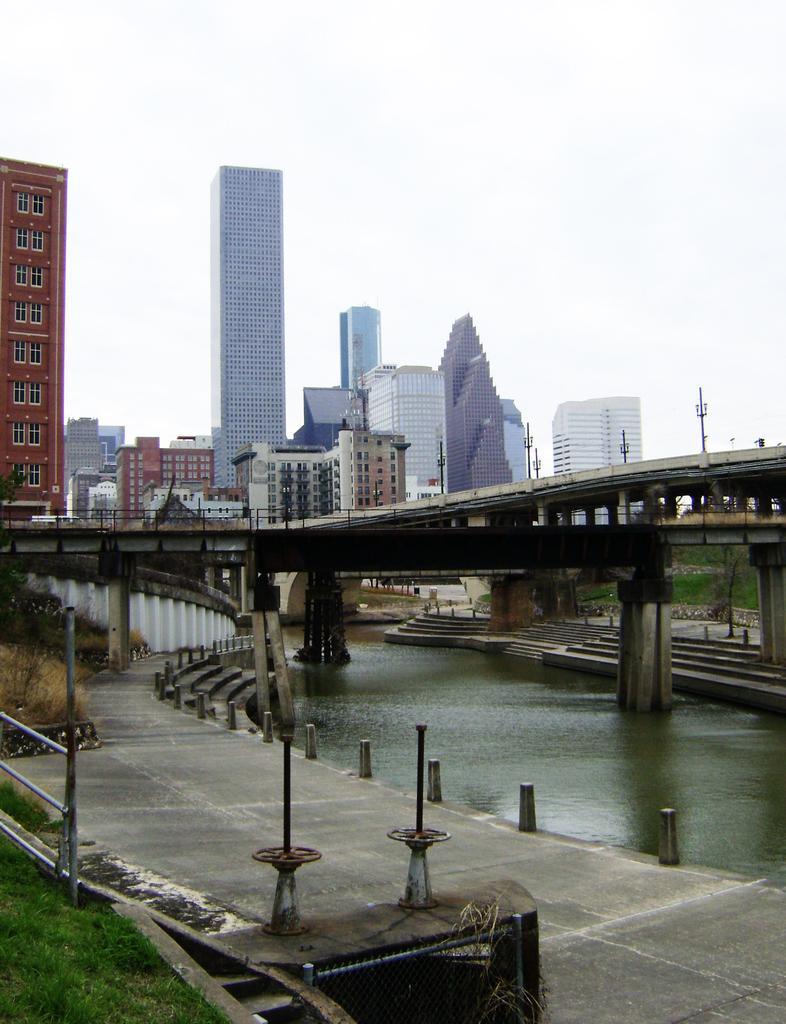Describe this image in one or two sentences. In this image we can see few bridges. We can see the sky in the image. There are few street lights in the image. We can see the water in the image. There is a grassy land in the image. There is a walkway in the image. We can see the sky in the image. 